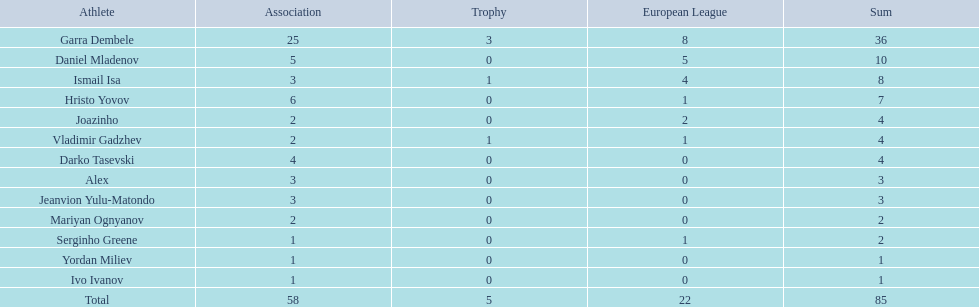How many players had a total of 4? 3. 